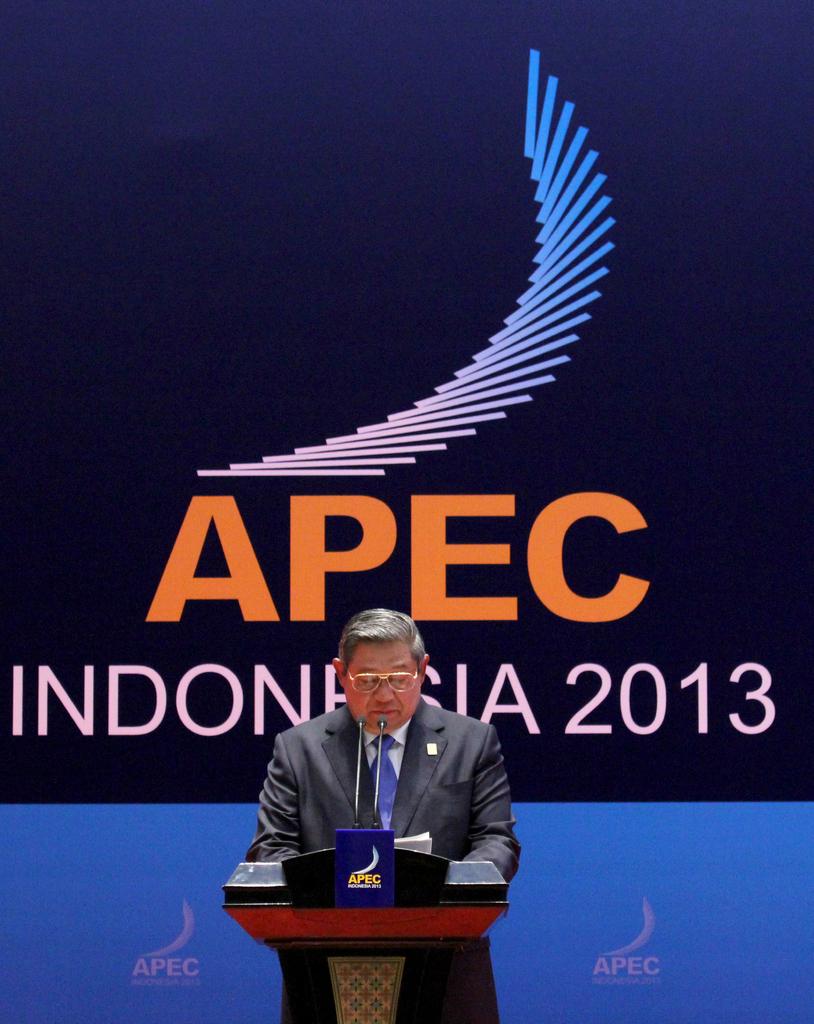What country is this in?
Make the answer very short. Indonesia. 